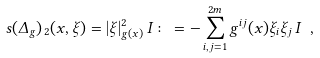<formula> <loc_0><loc_0><loc_500><loc_500>\ s ( \Delta _ { g } ) _ { \, 2 } ( x , \xi ) = | \xi | _ { g ( x ) } ^ { 2 } \, I \colon = - \sum _ { i , j = 1 } ^ { 2 m } g ^ { i j } ( x ) \xi _ { i } \xi _ { j } \, I \ ,</formula> 